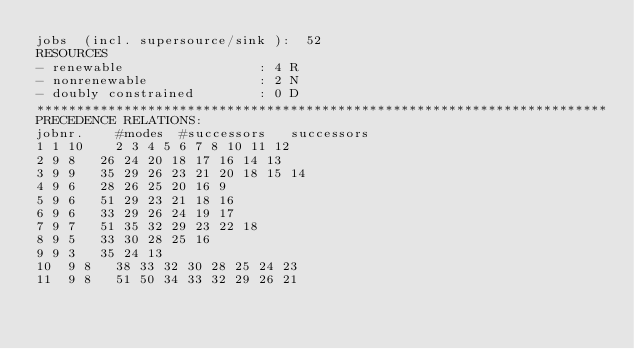Convert code to text. <code><loc_0><loc_0><loc_500><loc_500><_ObjectiveC_>jobs  (incl. supersource/sink ):	52
RESOURCES
- renewable                 : 4 R
- nonrenewable              : 2 N
- doubly constrained        : 0 D
************************************************************************
PRECEDENCE RELATIONS:
jobnr.    #modes  #successors   successors
1	1	10		2 3 4 5 6 7 8 10 11 12 
2	9	8		26 24 20 18 17 16 14 13 
3	9	9		35 29 26 23 21 20 18 15 14 
4	9	6		28 26 25 20 16 9 
5	9	6		51 29 23 21 18 16 
6	9	6		33 29 26 24 19 17 
7	9	7		51 35 32 29 23 22 18 
8	9	5		33 30 28 25 16 
9	9	3		35 24 13 
10	9	8		38 33 32 30 28 25 24 23 
11	9	8		51 50 34 33 32 29 26 21 </code> 